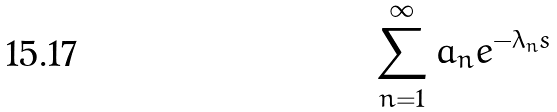<formula> <loc_0><loc_0><loc_500><loc_500>\sum _ { n = 1 } ^ { \infty } a _ { n } e ^ { - \lambda _ { n } s }</formula> 